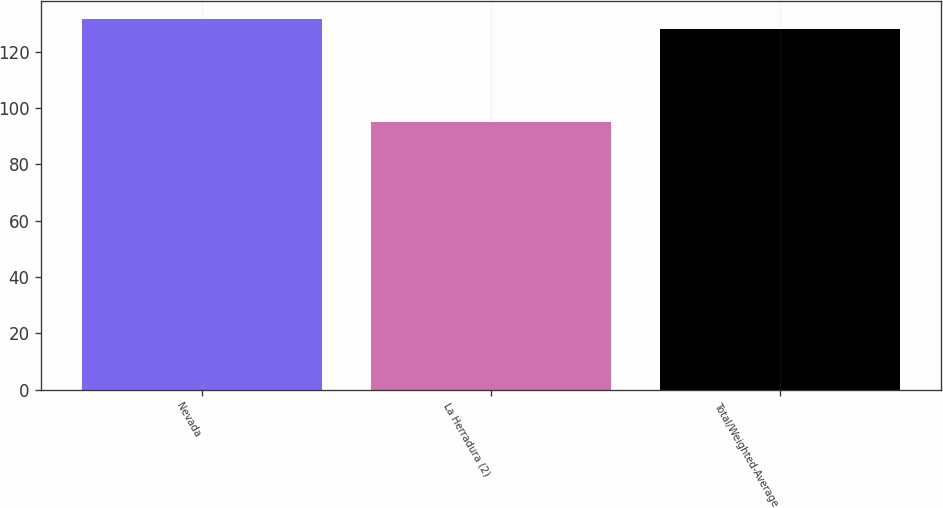Convert chart. <chart><loc_0><loc_0><loc_500><loc_500><bar_chart><fcel>Nevada<fcel>La Herradura (2)<fcel>Total/Weighted-Average<nl><fcel>131.5<fcel>95<fcel>128<nl></chart> 